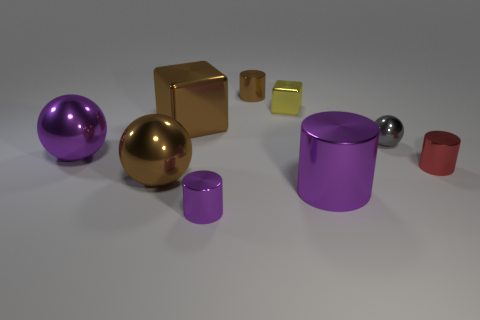Subtract 1 cylinders. How many cylinders are left? 3 Add 1 big metal blocks. How many objects exist? 10 Subtract all blocks. How many objects are left? 7 Add 7 purple things. How many purple things exist? 10 Subtract 0 cyan cylinders. How many objects are left? 9 Subtract all large purple spheres. Subtract all brown objects. How many objects are left? 5 Add 3 large brown blocks. How many large brown blocks are left? 4 